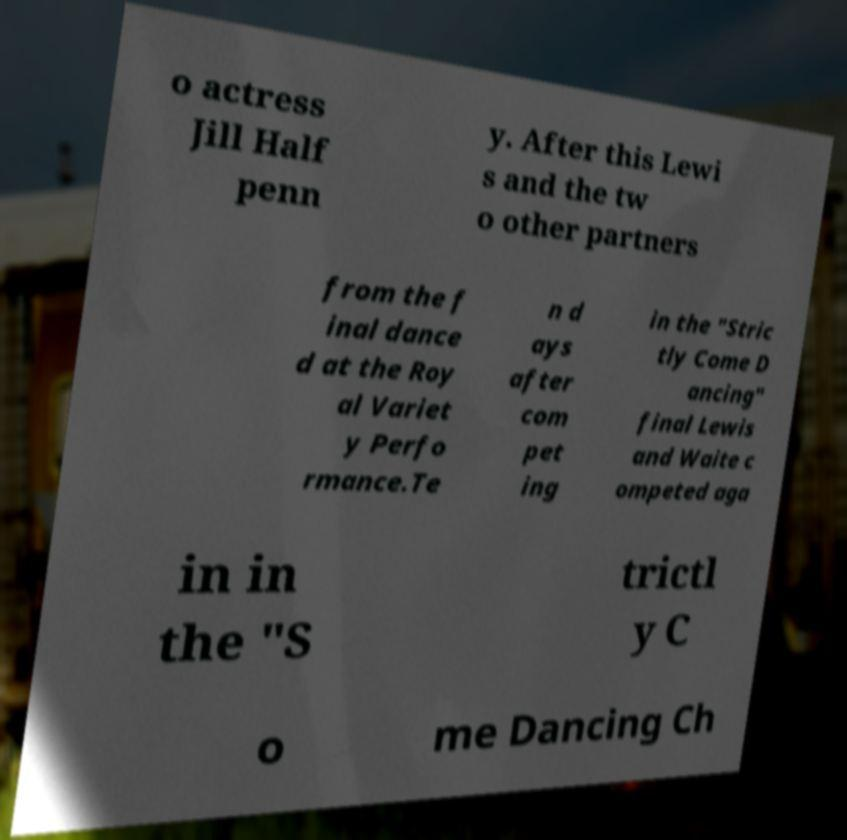Can you accurately transcribe the text from the provided image for me? o actress Jill Half penn y. After this Lewi s and the tw o other partners from the f inal dance d at the Roy al Variet y Perfo rmance.Te n d ays after com pet ing in the "Stric tly Come D ancing" final Lewis and Waite c ompeted aga in in the "S trictl y C o me Dancing Ch 